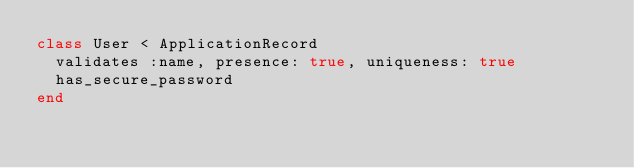Convert code to text. <code><loc_0><loc_0><loc_500><loc_500><_Ruby_>class User < ApplicationRecord
  validates :name, presence: true, uniqueness: true
  has_secure_password
end
</code> 